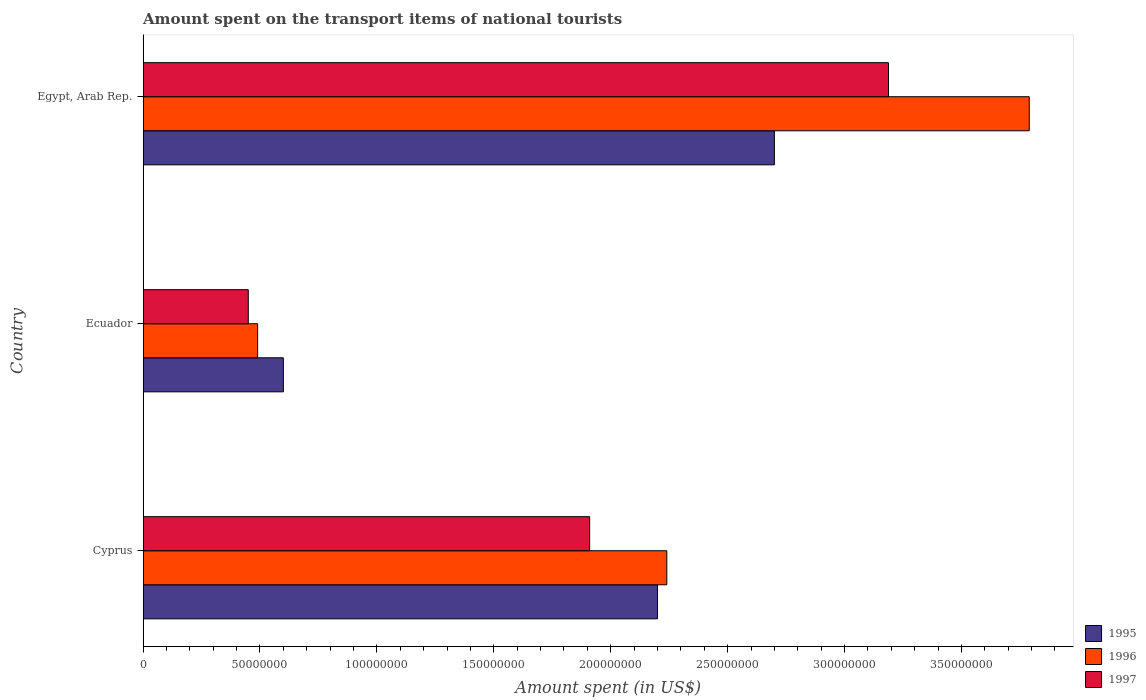How many different coloured bars are there?
Your answer should be very brief. 3. How many groups of bars are there?
Your response must be concise. 3. Are the number of bars on each tick of the Y-axis equal?
Give a very brief answer. Yes. What is the label of the 3rd group of bars from the top?
Your answer should be compact. Cyprus. What is the amount spent on the transport items of national tourists in 1997 in Egypt, Arab Rep.?
Make the answer very short. 3.19e+08. Across all countries, what is the maximum amount spent on the transport items of national tourists in 1997?
Your answer should be compact. 3.19e+08. Across all countries, what is the minimum amount spent on the transport items of national tourists in 1995?
Your answer should be very brief. 6.00e+07. In which country was the amount spent on the transport items of national tourists in 1995 maximum?
Ensure brevity in your answer.  Egypt, Arab Rep. In which country was the amount spent on the transport items of national tourists in 1997 minimum?
Ensure brevity in your answer.  Ecuador. What is the total amount spent on the transport items of national tourists in 1997 in the graph?
Ensure brevity in your answer.  5.55e+08. What is the difference between the amount spent on the transport items of national tourists in 1995 in Ecuador and that in Egypt, Arab Rep.?
Offer a terse response. -2.10e+08. What is the difference between the amount spent on the transport items of national tourists in 1995 in Cyprus and the amount spent on the transport items of national tourists in 1997 in Egypt, Arab Rep.?
Your response must be concise. -9.88e+07. What is the average amount spent on the transport items of national tourists in 1996 per country?
Provide a short and direct response. 2.17e+08. What is the difference between the amount spent on the transport items of national tourists in 1997 and amount spent on the transport items of national tourists in 1995 in Cyprus?
Keep it short and to the point. -2.90e+07. In how many countries, is the amount spent on the transport items of national tourists in 1997 greater than 10000000 US$?
Ensure brevity in your answer.  3. What is the ratio of the amount spent on the transport items of national tourists in 1996 in Cyprus to that in Egypt, Arab Rep.?
Ensure brevity in your answer.  0.59. What is the difference between the highest and the second highest amount spent on the transport items of national tourists in 1996?
Ensure brevity in your answer.  1.55e+08. What is the difference between the highest and the lowest amount spent on the transport items of national tourists in 1995?
Make the answer very short. 2.10e+08. In how many countries, is the amount spent on the transport items of national tourists in 1997 greater than the average amount spent on the transport items of national tourists in 1997 taken over all countries?
Make the answer very short. 2. What does the 1st bar from the top in Egypt, Arab Rep. represents?
Ensure brevity in your answer.  1997. How many bars are there?
Your answer should be very brief. 9. Are all the bars in the graph horizontal?
Ensure brevity in your answer.  Yes. How many countries are there in the graph?
Provide a short and direct response. 3. What is the difference between two consecutive major ticks on the X-axis?
Give a very brief answer. 5.00e+07. Does the graph contain grids?
Offer a very short reply. No. Where does the legend appear in the graph?
Keep it short and to the point. Bottom right. What is the title of the graph?
Keep it short and to the point. Amount spent on the transport items of national tourists. What is the label or title of the X-axis?
Give a very brief answer. Amount spent (in US$). What is the Amount spent (in US$) of 1995 in Cyprus?
Make the answer very short. 2.20e+08. What is the Amount spent (in US$) in 1996 in Cyprus?
Your answer should be very brief. 2.24e+08. What is the Amount spent (in US$) in 1997 in Cyprus?
Make the answer very short. 1.91e+08. What is the Amount spent (in US$) in 1995 in Ecuador?
Your answer should be very brief. 6.00e+07. What is the Amount spent (in US$) in 1996 in Ecuador?
Offer a very short reply. 4.90e+07. What is the Amount spent (in US$) of 1997 in Ecuador?
Ensure brevity in your answer.  4.50e+07. What is the Amount spent (in US$) in 1995 in Egypt, Arab Rep.?
Your answer should be compact. 2.70e+08. What is the Amount spent (in US$) of 1996 in Egypt, Arab Rep.?
Ensure brevity in your answer.  3.79e+08. What is the Amount spent (in US$) of 1997 in Egypt, Arab Rep.?
Provide a succinct answer. 3.19e+08. Across all countries, what is the maximum Amount spent (in US$) of 1995?
Offer a very short reply. 2.70e+08. Across all countries, what is the maximum Amount spent (in US$) of 1996?
Provide a short and direct response. 3.79e+08. Across all countries, what is the maximum Amount spent (in US$) in 1997?
Give a very brief answer. 3.19e+08. Across all countries, what is the minimum Amount spent (in US$) in 1995?
Your response must be concise. 6.00e+07. Across all countries, what is the minimum Amount spent (in US$) in 1996?
Your answer should be very brief. 4.90e+07. Across all countries, what is the minimum Amount spent (in US$) of 1997?
Make the answer very short. 4.50e+07. What is the total Amount spent (in US$) in 1995 in the graph?
Your answer should be compact. 5.50e+08. What is the total Amount spent (in US$) in 1996 in the graph?
Keep it short and to the point. 6.52e+08. What is the total Amount spent (in US$) of 1997 in the graph?
Give a very brief answer. 5.55e+08. What is the difference between the Amount spent (in US$) in 1995 in Cyprus and that in Ecuador?
Your response must be concise. 1.60e+08. What is the difference between the Amount spent (in US$) of 1996 in Cyprus and that in Ecuador?
Provide a succinct answer. 1.75e+08. What is the difference between the Amount spent (in US$) in 1997 in Cyprus and that in Ecuador?
Keep it short and to the point. 1.46e+08. What is the difference between the Amount spent (in US$) in 1995 in Cyprus and that in Egypt, Arab Rep.?
Provide a succinct answer. -5.00e+07. What is the difference between the Amount spent (in US$) in 1996 in Cyprus and that in Egypt, Arab Rep.?
Your response must be concise. -1.55e+08. What is the difference between the Amount spent (in US$) in 1997 in Cyprus and that in Egypt, Arab Rep.?
Your response must be concise. -1.28e+08. What is the difference between the Amount spent (in US$) of 1995 in Ecuador and that in Egypt, Arab Rep.?
Provide a short and direct response. -2.10e+08. What is the difference between the Amount spent (in US$) of 1996 in Ecuador and that in Egypt, Arab Rep.?
Make the answer very short. -3.30e+08. What is the difference between the Amount spent (in US$) of 1997 in Ecuador and that in Egypt, Arab Rep.?
Offer a very short reply. -2.74e+08. What is the difference between the Amount spent (in US$) of 1995 in Cyprus and the Amount spent (in US$) of 1996 in Ecuador?
Offer a very short reply. 1.71e+08. What is the difference between the Amount spent (in US$) in 1995 in Cyprus and the Amount spent (in US$) in 1997 in Ecuador?
Give a very brief answer. 1.75e+08. What is the difference between the Amount spent (in US$) of 1996 in Cyprus and the Amount spent (in US$) of 1997 in Ecuador?
Make the answer very short. 1.79e+08. What is the difference between the Amount spent (in US$) in 1995 in Cyprus and the Amount spent (in US$) in 1996 in Egypt, Arab Rep.?
Your response must be concise. -1.59e+08. What is the difference between the Amount spent (in US$) of 1995 in Cyprus and the Amount spent (in US$) of 1997 in Egypt, Arab Rep.?
Make the answer very short. -9.88e+07. What is the difference between the Amount spent (in US$) of 1996 in Cyprus and the Amount spent (in US$) of 1997 in Egypt, Arab Rep.?
Your answer should be very brief. -9.48e+07. What is the difference between the Amount spent (in US$) in 1995 in Ecuador and the Amount spent (in US$) in 1996 in Egypt, Arab Rep.?
Your answer should be compact. -3.19e+08. What is the difference between the Amount spent (in US$) in 1995 in Ecuador and the Amount spent (in US$) in 1997 in Egypt, Arab Rep.?
Ensure brevity in your answer.  -2.59e+08. What is the difference between the Amount spent (in US$) of 1996 in Ecuador and the Amount spent (in US$) of 1997 in Egypt, Arab Rep.?
Provide a short and direct response. -2.70e+08. What is the average Amount spent (in US$) in 1995 per country?
Provide a succinct answer. 1.83e+08. What is the average Amount spent (in US$) in 1996 per country?
Make the answer very short. 2.17e+08. What is the average Amount spent (in US$) of 1997 per country?
Offer a very short reply. 1.85e+08. What is the difference between the Amount spent (in US$) in 1995 and Amount spent (in US$) in 1996 in Cyprus?
Provide a short and direct response. -4.00e+06. What is the difference between the Amount spent (in US$) of 1995 and Amount spent (in US$) of 1997 in Cyprus?
Give a very brief answer. 2.90e+07. What is the difference between the Amount spent (in US$) in 1996 and Amount spent (in US$) in 1997 in Cyprus?
Your answer should be very brief. 3.30e+07. What is the difference between the Amount spent (in US$) in 1995 and Amount spent (in US$) in 1996 in Ecuador?
Provide a succinct answer. 1.10e+07. What is the difference between the Amount spent (in US$) of 1995 and Amount spent (in US$) of 1997 in Ecuador?
Offer a terse response. 1.50e+07. What is the difference between the Amount spent (in US$) of 1995 and Amount spent (in US$) of 1996 in Egypt, Arab Rep.?
Keep it short and to the point. -1.09e+08. What is the difference between the Amount spent (in US$) in 1995 and Amount spent (in US$) in 1997 in Egypt, Arab Rep.?
Make the answer very short. -4.88e+07. What is the difference between the Amount spent (in US$) of 1996 and Amount spent (in US$) of 1997 in Egypt, Arab Rep.?
Provide a succinct answer. 6.02e+07. What is the ratio of the Amount spent (in US$) in 1995 in Cyprus to that in Ecuador?
Your response must be concise. 3.67. What is the ratio of the Amount spent (in US$) in 1996 in Cyprus to that in Ecuador?
Provide a short and direct response. 4.57. What is the ratio of the Amount spent (in US$) of 1997 in Cyprus to that in Ecuador?
Ensure brevity in your answer.  4.24. What is the ratio of the Amount spent (in US$) in 1995 in Cyprus to that in Egypt, Arab Rep.?
Your answer should be compact. 0.81. What is the ratio of the Amount spent (in US$) in 1996 in Cyprus to that in Egypt, Arab Rep.?
Give a very brief answer. 0.59. What is the ratio of the Amount spent (in US$) of 1997 in Cyprus to that in Egypt, Arab Rep.?
Give a very brief answer. 0.6. What is the ratio of the Amount spent (in US$) of 1995 in Ecuador to that in Egypt, Arab Rep.?
Provide a short and direct response. 0.22. What is the ratio of the Amount spent (in US$) in 1996 in Ecuador to that in Egypt, Arab Rep.?
Keep it short and to the point. 0.13. What is the ratio of the Amount spent (in US$) in 1997 in Ecuador to that in Egypt, Arab Rep.?
Your answer should be very brief. 0.14. What is the difference between the highest and the second highest Amount spent (in US$) of 1995?
Your answer should be very brief. 5.00e+07. What is the difference between the highest and the second highest Amount spent (in US$) in 1996?
Give a very brief answer. 1.55e+08. What is the difference between the highest and the second highest Amount spent (in US$) of 1997?
Make the answer very short. 1.28e+08. What is the difference between the highest and the lowest Amount spent (in US$) of 1995?
Your answer should be compact. 2.10e+08. What is the difference between the highest and the lowest Amount spent (in US$) of 1996?
Ensure brevity in your answer.  3.30e+08. What is the difference between the highest and the lowest Amount spent (in US$) in 1997?
Give a very brief answer. 2.74e+08. 